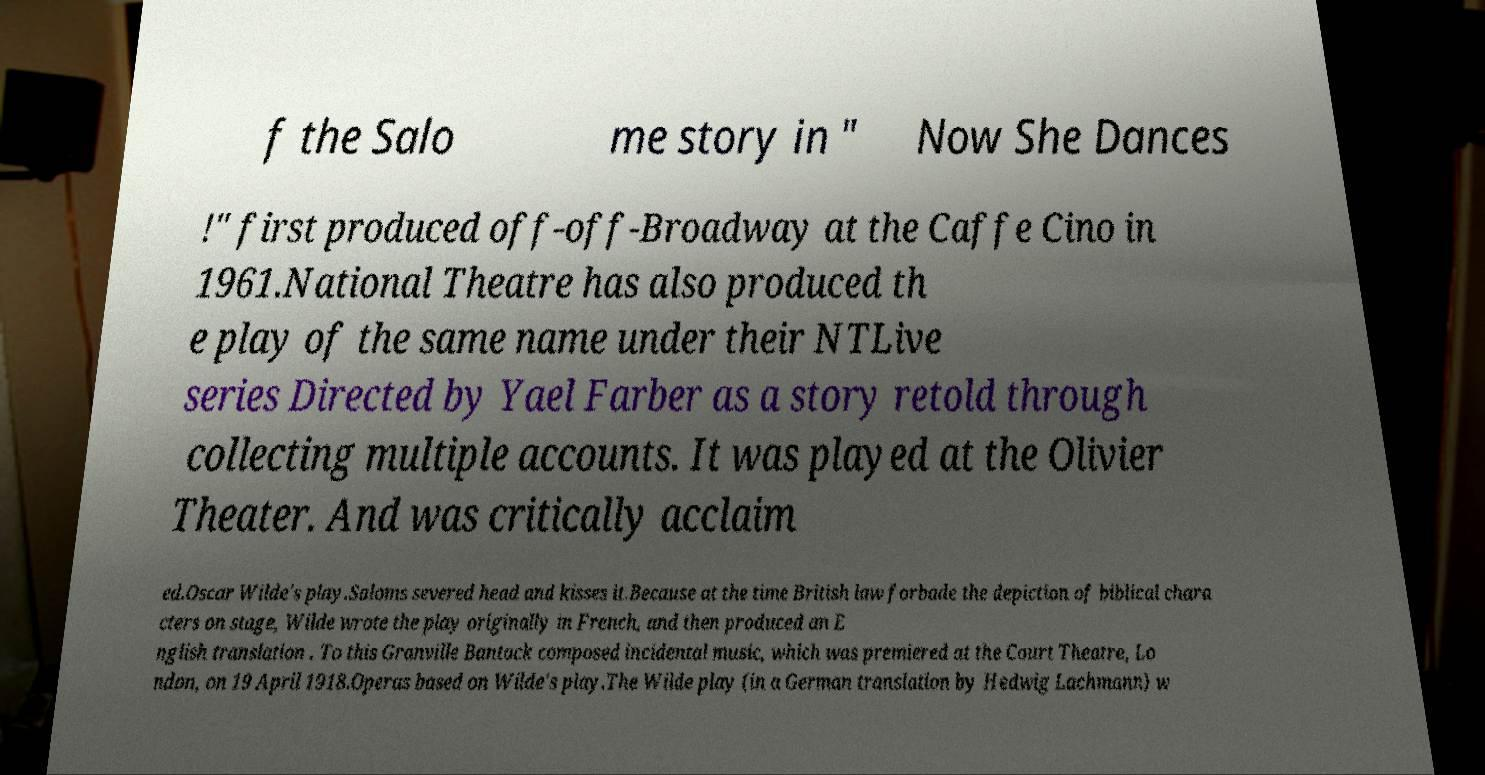Could you assist in decoding the text presented in this image and type it out clearly? f the Salo me story in " Now She Dances !" first produced off-off-Broadway at the Caffe Cino in 1961.National Theatre has also produced th e play of the same name under their NTLive series Directed by Yael Farber as a story retold through collecting multiple accounts. It was played at the Olivier Theater. And was critically acclaim ed.Oscar Wilde's play.Saloms severed head and kisses it.Because at the time British law forbade the depiction of biblical chara cters on stage, Wilde wrote the play originally in French, and then produced an E nglish translation . To this Granville Bantock composed incidental music, which was premiered at the Court Theatre, Lo ndon, on 19 April 1918.Operas based on Wilde's play.The Wilde play (in a German translation by Hedwig Lachmann) w 